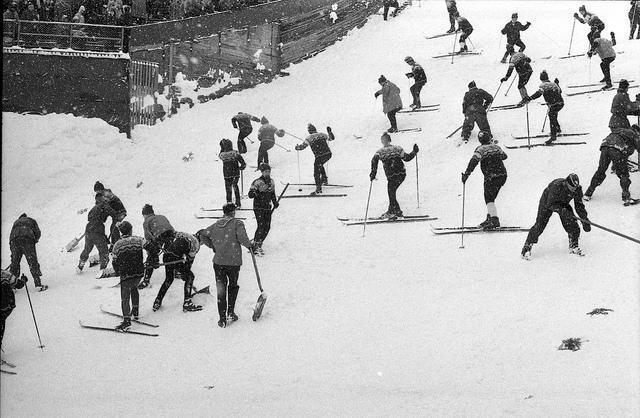How many people can be seen?
Give a very brief answer. 6. 